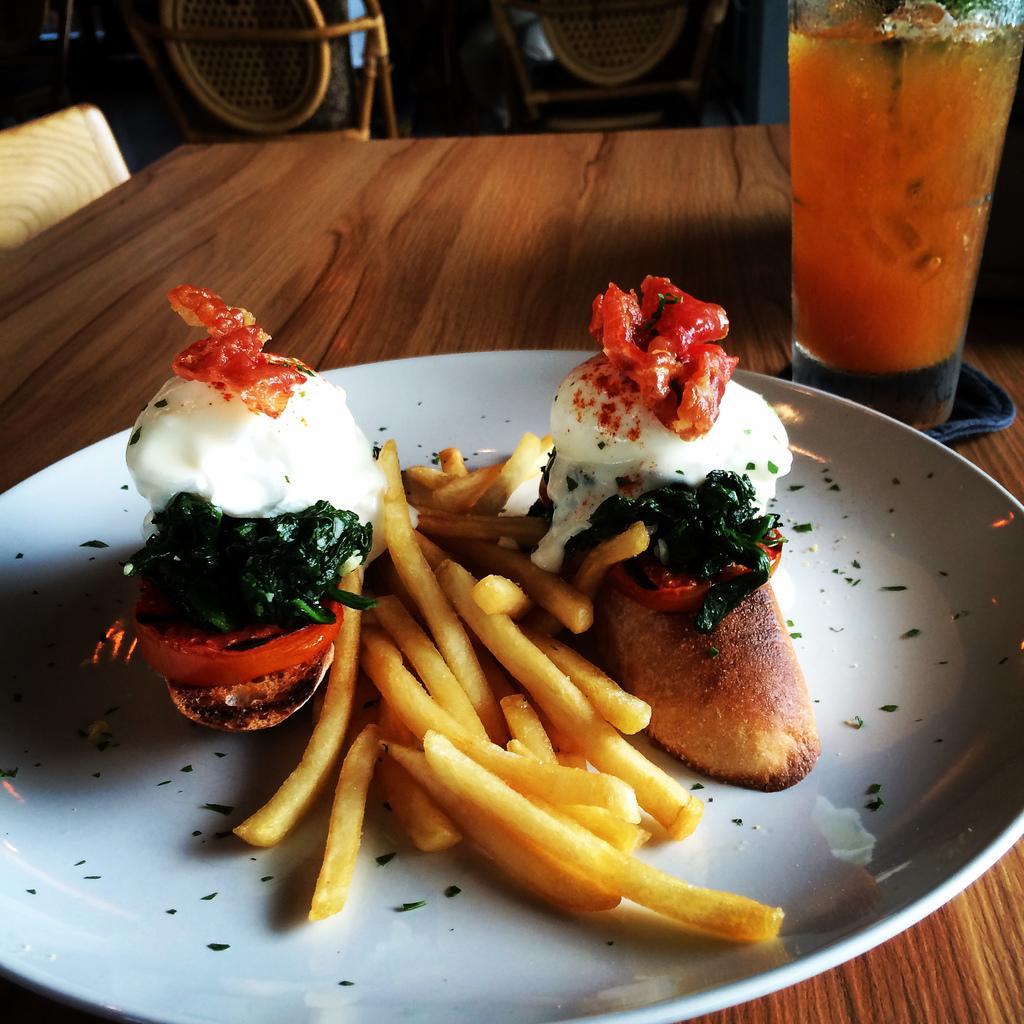How would you summarize this image in a sentence or two? In this picture we can see food in the plate, beside the plate we can find a glass on the table and we can see drink in the glass, in the background we can find few chairs. 